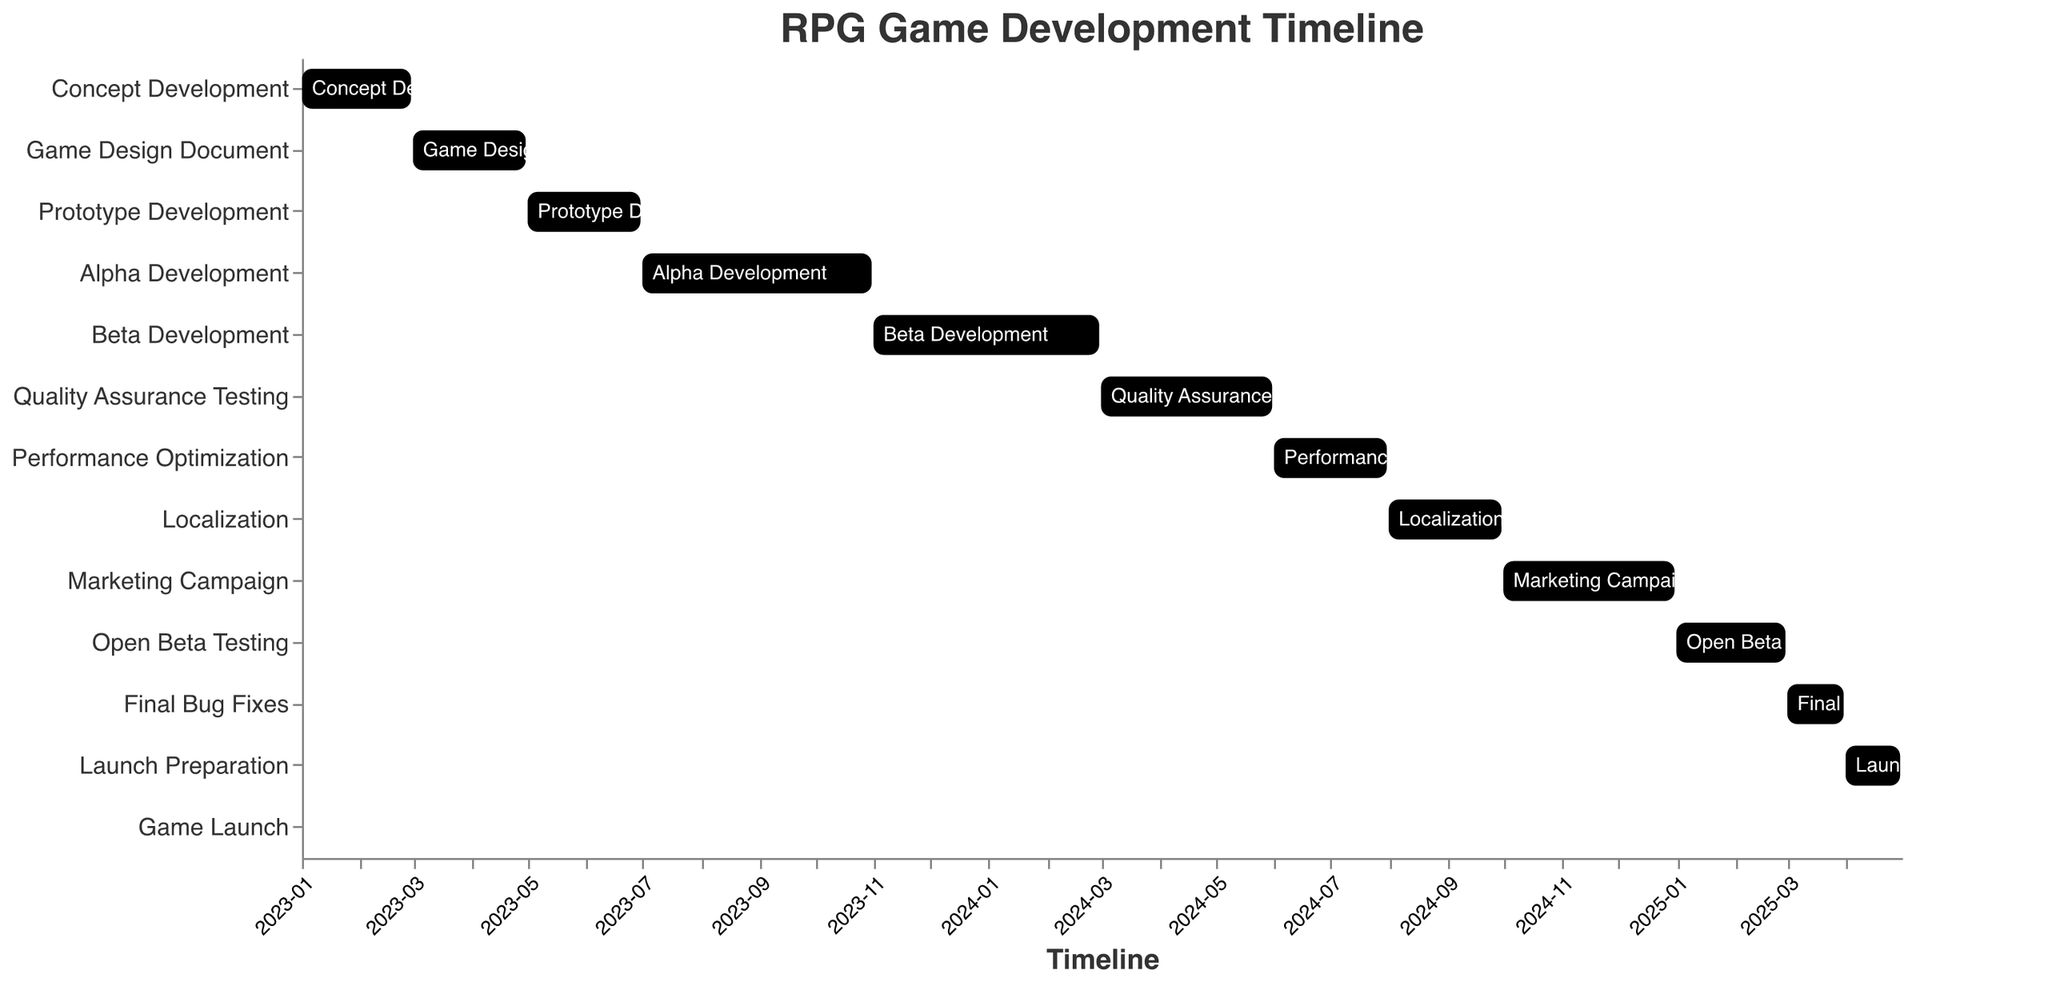Which task starts immediately after Prototype Development? To determine which task starts immediately after Prototype Development, locate its end date, which is on 2023-06-30, and see the next task's start date. The next task, Alpha Development, starts on 2023-07-01.
Answer: Alpha Development How long does the Alpha Development phase last? To determine the duration of the Alpha Development phase, find its start and end dates, which are 2023-07-01 and 2023-10-31, respectively. Subtract the start date from the end date.
Answer: 4 months How many phases are scheduled between Quality Assurance Testing and Game Launch? Count the number of tasks between Quality Assurance Testing (end date: 2024-05-31) and Game Launch (start date: 2025-05-01). The phases are Performance Optimization, Localization, Marketing Campaign, Open Beta Testing, Final Bug Fixes, and Launch Preparation.
Answer: 6 phases Which phase has the shortest duration? To find the shortest duration, examine the start and end dates of all tasks. The task "Game Launch" has both its start and end date on 2025-05-01, making it the shortest.
Answer: Game Launch What is the total duration from the beginning of Concept Development to the end of Launch Preparation? Calculate the total duration by subtracting the start date of Concept Development (2023-01-01) from the end date of Launch Preparation (2025-04-30).
Answer: 2 years and 4 months Which tasks overlap with the Marketing Campaign phase? The Marketing Campaign phase runs from 2024-10-01 to 2024-12-31. Identify tasks with dates that overlap with this period. Open Beta Testing starts 2025-01-01, meaning no tasks overlap with Marketing Campaign.
Answer: None What are the overlapping dates for Alpha Development and Beta Development? Find the overlap between Alpha Development (2023-07-01 to 2023-10-31) and Beta Development (2023-11-01 to 2024-02-29). Since Beta Development starts right after Alpha Development ends, there is no overlap.
Answer: No overlap Which phases contribute to the second half of 2024? Identify phases with dates overlapping the second half of 2024 (from 2024-07-01 to 2024-12-31). They are Performance Optimization, Localization, and Marketing Campaign.
Answer: Performance Optimization, Localization, Marketing Campaign 